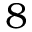Convert formula to latex. <formula><loc_0><loc_0><loc_500><loc_500>8</formula> 